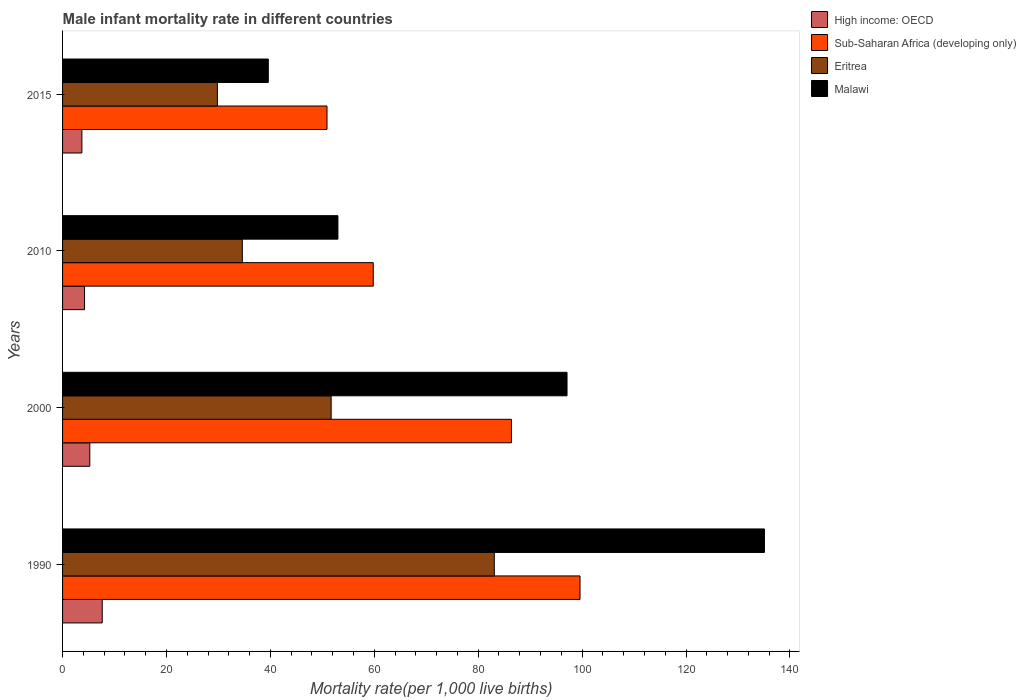How many different coloured bars are there?
Make the answer very short. 4. Are the number of bars on each tick of the Y-axis equal?
Your response must be concise. Yes. How many bars are there on the 3rd tick from the top?
Provide a short and direct response. 4. What is the label of the 1st group of bars from the top?
Offer a very short reply. 2015. What is the male infant mortality rate in Malawi in 2000?
Provide a short and direct response. 97.1. Across all years, what is the maximum male infant mortality rate in Sub-Saharan Africa (developing only)?
Make the answer very short. 99.6. Across all years, what is the minimum male infant mortality rate in Malawi?
Ensure brevity in your answer.  39.6. In which year was the male infant mortality rate in Malawi minimum?
Ensure brevity in your answer.  2015. What is the total male infant mortality rate in Malawi in the graph?
Provide a succinct answer. 324.8. What is the difference between the male infant mortality rate in High income: OECD in 2010 and that in 2015?
Keep it short and to the point. 0.51. What is the difference between the male infant mortality rate in Sub-Saharan Africa (developing only) in 1990 and the male infant mortality rate in Malawi in 2000?
Offer a terse response. 2.5. What is the average male infant mortality rate in Sub-Saharan Africa (developing only) per year?
Ensure brevity in your answer.  74.17. In the year 1990, what is the difference between the male infant mortality rate in Eritrea and male infant mortality rate in Sub-Saharan Africa (developing only)?
Ensure brevity in your answer.  -16.5. What is the ratio of the male infant mortality rate in Sub-Saharan Africa (developing only) in 2000 to that in 2015?
Give a very brief answer. 1.7. Is the male infant mortality rate in Malawi in 1990 less than that in 2000?
Ensure brevity in your answer.  No. Is the difference between the male infant mortality rate in Eritrea in 1990 and 2015 greater than the difference between the male infant mortality rate in Sub-Saharan Africa (developing only) in 1990 and 2015?
Provide a succinct answer. Yes. What is the difference between the highest and the second highest male infant mortality rate in Eritrea?
Your answer should be compact. 31.4. What is the difference between the highest and the lowest male infant mortality rate in Malawi?
Give a very brief answer. 95.5. In how many years, is the male infant mortality rate in Malawi greater than the average male infant mortality rate in Malawi taken over all years?
Your answer should be very brief. 2. What does the 4th bar from the top in 2000 represents?
Ensure brevity in your answer.  High income: OECD. What does the 4th bar from the bottom in 2015 represents?
Offer a very short reply. Malawi. Is it the case that in every year, the sum of the male infant mortality rate in Malawi and male infant mortality rate in Eritrea is greater than the male infant mortality rate in Sub-Saharan Africa (developing only)?
Your answer should be very brief. Yes. Are all the bars in the graph horizontal?
Offer a very short reply. Yes. How many years are there in the graph?
Your response must be concise. 4. Are the values on the major ticks of X-axis written in scientific E-notation?
Provide a succinct answer. No. Where does the legend appear in the graph?
Give a very brief answer. Top right. How many legend labels are there?
Offer a very short reply. 4. How are the legend labels stacked?
Your response must be concise. Vertical. What is the title of the graph?
Ensure brevity in your answer.  Male infant mortality rate in different countries. What is the label or title of the X-axis?
Offer a very short reply. Mortality rate(per 1,0 live births). What is the Mortality rate(per 1,000 live births) of High income: OECD in 1990?
Offer a terse response. 7.64. What is the Mortality rate(per 1,000 live births) in Sub-Saharan Africa (developing only) in 1990?
Offer a terse response. 99.6. What is the Mortality rate(per 1,000 live births) of Eritrea in 1990?
Offer a very short reply. 83.1. What is the Mortality rate(per 1,000 live births) in Malawi in 1990?
Ensure brevity in your answer.  135.1. What is the Mortality rate(per 1,000 live births) in High income: OECD in 2000?
Provide a short and direct response. 5.24. What is the Mortality rate(per 1,000 live births) of Sub-Saharan Africa (developing only) in 2000?
Ensure brevity in your answer.  86.4. What is the Mortality rate(per 1,000 live births) in Eritrea in 2000?
Offer a terse response. 51.7. What is the Mortality rate(per 1,000 live births) of Malawi in 2000?
Offer a terse response. 97.1. What is the Mortality rate(per 1,000 live births) in High income: OECD in 2010?
Provide a short and direct response. 4.23. What is the Mortality rate(per 1,000 live births) in Sub-Saharan Africa (developing only) in 2010?
Make the answer very short. 59.8. What is the Mortality rate(per 1,000 live births) of Eritrea in 2010?
Provide a short and direct response. 34.6. What is the Mortality rate(per 1,000 live births) of High income: OECD in 2015?
Ensure brevity in your answer.  3.72. What is the Mortality rate(per 1,000 live births) of Sub-Saharan Africa (developing only) in 2015?
Provide a succinct answer. 50.9. What is the Mortality rate(per 1,000 live births) of Eritrea in 2015?
Provide a succinct answer. 29.8. What is the Mortality rate(per 1,000 live births) in Malawi in 2015?
Make the answer very short. 39.6. Across all years, what is the maximum Mortality rate(per 1,000 live births) of High income: OECD?
Keep it short and to the point. 7.64. Across all years, what is the maximum Mortality rate(per 1,000 live births) of Sub-Saharan Africa (developing only)?
Provide a short and direct response. 99.6. Across all years, what is the maximum Mortality rate(per 1,000 live births) of Eritrea?
Your answer should be very brief. 83.1. Across all years, what is the maximum Mortality rate(per 1,000 live births) of Malawi?
Give a very brief answer. 135.1. Across all years, what is the minimum Mortality rate(per 1,000 live births) in High income: OECD?
Keep it short and to the point. 3.72. Across all years, what is the minimum Mortality rate(per 1,000 live births) in Sub-Saharan Africa (developing only)?
Your answer should be very brief. 50.9. Across all years, what is the minimum Mortality rate(per 1,000 live births) in Eritrea?
Ensure brevity in your answer.  29.8. Across all years, what is the minimum Mortality rate(per 1,000 live births) in Malawi?
Offer a very short reply. 39.6. What is the total Mortality rate(per 1,000 live births) of High income: OECD in the graph?
Give a very brief answer. 20.82. What is the total Mortality rate(per 1,000 live births) of Sub-Saharan Africa (developing only) in the graph?
Give a very brief answer. 296.7. What is the total Mortality rate(per 1,000 live births) in Eritrea in the graph?
Offer a terse response. 199.2. What is the total Mortality rate(per 1,000 live births) in Malawi in the graph?
Provide a short and direct response. 324.8. What is the difference between the Mortality rate(per 1,000 live births) in High income: OECD in 1990 and that in 2000?
Make the answer very short. 2.39. What is the difference between the Mortality rate(per 1,000 live births) of Sub-Saharan Africa (developing only) in 1990 and that in 2000?
Provide a succinct answer. 13.2. What is the difference between the Mortality rate(per 1,000 live births) of Eritrea in 1990 and that in 2000?
Provide a short and direct response. 31.4. What is the difference between the Mortality rate(per 1,000 live births) of High income: OECD in 1990 and that in 2010?
Provide a succinct answer. 3.41. What is the difference between the Mortality rate(per 1,000 live births) of Sub-Saharan Africa (developing only) in 1990 and that in 2010?
Your response must be concise. 39.8. What is the difference between the Mortality rate(per 1,000 live births) in Eritrea in 1990 and that in 2010?
Give a very brief answer. 48.5. What is the difference between the Mortality rate(per 1,000 live births) of Malawi in 1990 and that in 2010?
Keep it short and to the point. 82.1. What is the difference between the Mortality rate(per 1,000 live births) in High income: OECD in 1990 and that in 2015?
Offer a very short reply. 3.92. What is the difference between the Mortality rate(per 1,000 live births) in Sub-Saharan Africa (developing only) in 1990 and that in 2015?
Give a very brief answer. 48.7. What is the difference between the Mortality rate(per 1,000 live births) of Eritrea in 1990 and that in 2015?
Your answer should be very brief. 53.3. What is the difference between the Mortality rate(per 1,000 live births) in Malawi in 1990 and that in 2015?
Your answer should be compact. 95.5. What is the difference between the Mortality rate(per 1,000 live births) of High income: OECD in 2000 and that in 2010?
Offer a terse response. 1.01. What is the difference between the Mortality rate(per 1,000 live births) of Sub-Saharan Africa (developing only) in 2000 and that in 2010?
Offer a terse response. 26.6. What is the difference between the Mortality rate(per 1,000 live births) of Eritrea in 2000 and that in 2010?
Offer a terse response. 17.1. What is the difference between the Mortality rate(per 1,000 live births) in Malawi in 2000 and that in 2010?
Your answer should be very brief. 44.1. What is the difference between the Mortality rate(per 1,000 live births) in High income: OECD in 2000 and that in 2015?
Your answer should be compact. 1.52. What is the difference between the Mortality rate(per 1,000 live births) of Sub-Saharan Africa (developing only) in 2000 and that in 2015?
Provide a succinct answer. 35.5. What is the difference between the Mortality rate(per 1,000 live births) in Eritrea in 2000 and that in 2015?
Your response must be concise. 21.9. What is the difference between the Mortality rate(per 1,000 live births) in Malawi in 2000 and that in 2015?
Offer a very short reply. 57.5. What is the difference between the Mortality rate(per 1,000 live births) in High income: OECD in 2010 and that in 2015?
Offer a terse response. 0.51. What is the difference between the Mortality rate(per 1,000 live births) in High income: OECD in 1990 and the Mortality rate(per 1,000 live births) in Sub-Saharan Africa (developing only) in 2000?
Your answer should be compact. -78.76. What is the difference between the Mortality rate(per 1,000 live births) of High income: OECD in 1990 and the Mortality rate(per 1,000 live births) of Eritrea in 2000?
Your answer should be compact. -44.06. What is the difference between the Mortality rate(per 1,000 live births) of High income: OECD in 1990 and the Mortality rate(per 1,000 live births) of Malawi in 2000?
Your answer should be compact. -89.46. What is the difference between the Mortality rate(per 1,000 live births) in Sub-Saharan Africa (developing only) in 1990 and the Mortality rate(per 1,000 live births) in Eritrea in 2000?
Your response must be concise. 47.9. What is the difference between the Mortality rate(per 1,000 live births) in Sub-Saharan Africa (developing only) in 1990 and the Mortality rate(per 1,000 live births) in Malawi in 2000?
Make the answer very short. 2.5. What is the difference between the Mortality rate(per 1,000 live births) in High income: OECD in 1990 and the Mortality rate(per 1,000 live births) in Sub-Saharan Africa (developing only) in 2010?
Provide a short and direct response. -52.16. What is the difference between the Mortality rate(per 1,000 live births) of High income: OECD in 1990 and the Mortality rate(per 1,000 live births) of Eritrea in 2010?
Ensure brevity in your answer.  -26.96. What is the difference between the Mortality rate(per 1,000 live births) of High income: OECD in 1990 and the Mortality rate(per 1,000 live births) of Malawi in 2010?
Make the answer very short. -45.36. What is the difference between the Mortality rate(per 1,000 live births) of Sub-Saharan Africa (developing only) in 1990 and the Mortality rate(per 1,000 live births) of Malawi in 2010?
Provide a short and direct response. 46.6. What is the difference between the Mortality rate(per 1,000 live births) of Eritrea in 1990 and the Mortality rate(per 1,000 live births) of Malawi in 2010?
Keep it short and to the point. 30.1. What is the difference between the Mortality rate(per 1,000 live births) of High income: OECD in 1990 and the Mortality rate(per 1,000 live births) of Sub-Saharan Africa (developing only) in 2015?
Keep it short and to the point. -43.26. What is the difference between the Mortality rate(per 1,000 live births) in High income: OECD in 1990 and the Mortality rate(per 1,000 live births) in Eritrea in 2015?
Your answer should be very brief. -22.16. What is the difference between the Mortality rate(per 1,000 live births) of High income: OECD in 1990 and the Mortality rate(per 1,000 live births) of Malawi in 2015?
Offer a very short reply. -31.96. What is the difference between the Mortality rate(per 1,000 live births) of Sub-Saharan Africa (developing only) in 1990 and the Mortality rate(per 1,000 live births) of Eritrea in 2015?
Ensure brevity in your answer.  69.8. What is the difference between the Mortality rate(per 1,000 live births) of Sub-Saharan Africa (developing only) in 1990 and the Mortality rate(per 1,000 live births) of Malawi in 2015?
Offer a very short reply. 60. What is the difference between the Mortality rate(per 1,000 live births) in Eritrea in 1990 and the Mortality rate(per 1,000 live births) in Malawi in 2015?
Your answer should be compact. 43.5. What is the difference between the Mortality rate(per 1,000 live births) in High income: OECD in 2000 and the Mortality rate(per 1,000 live births) in Sub-Saharan Africa (developing only) in 2010?
Give a very brief answer. -54.56. What is the difference between the Mortality rate(per 1,000 live births) of High income: OECD in 2000 and the Mortality rate(per 1,000 live births) of Eritrea in 2010?
Provide a short and direct response. -29.36. What is the difference between the Mortality rate(per 1,000 live births) in High income: OECD in 2000 and the Mortality rate(per 1,000 live births) in Malawi in 2010?
Ensure brevity in your answer.  -47.76. What is the difference between the Mortality rate(per 1,000 live births) in Sub-Saharan Africa (developing only) in 2000 and the Mortality rate(per 1,000 live births) in Eritrea in 2010?
Your answer should be compact. 51.8. What is the difference between the Mortality rate(per 1,000 live births) in Sub-Saharan Africa (developing only) in 2000 and the Mortality rate(per 1,000 live births) in Malawi in 2010?
Keep it short and to the point. 33.4. What is the difference between the Mortality rate(per 1,000 live births) of Eritrea in 2000 and the Mortality rate(per 1,000 live births) of Malawi in 2010?
Ensure brevity in your answer.  -1.3. What is the difference between the Mortality rate(per 1,000 live births) in High income: OECD in 2000 and the Mortality rate(per 1,000 live births) in Sub-Saharan Africa (developing only) in 2015?
Make the answer very short. -45.66. What is the difference between the Mortality rate(per 1,000 live births) of High income: OECD in 2000 and the Mortality rate(per 1,000 live births) of Eritrea in 2015?
Give a very brief answer. -24.56. What is the difference between the Mortality rate(per 1,000 live births) in High income: OECD in 2000 and the Mortality rate(per 1,000 live births) in Malawi in 2015?
Ensure brevity in your answer.  -34.36. What is the difference between the Mortality rate(per 1,000 live births) in Sub-Saharan Africa (developing only) in 2000 and the Mortality rate(per 1,000 live births) in Eritrea in 2015?
Keep it short and to the point. 56.6. What is the difference between the Mortality rate(per 1,000 live births) in Sub-Saharan Africa (developing only) in 2000 and the Mortality rate(per 1,000 live births) in Malawi in 2015?
Give a very brief answer. 46.8. What is the difference between the Mortality rate(per 1,000 live births) of Eritrea in 2000 and the Mortality rate(per 1,000 live births) of Malawi in 2015?
Offer a very short reply. 12.1. What is the difference between the Mortality rate(per 1,000 live births) of High income: OECD in 2010 and the Mortality rate(per 1,000 live births) of Sub-Saharan Africa (developing only) in 2015?
Your answer should be very brief. -46.67. What is the difference between the Mortality rate(per 1,000 live births) of High income: OECD in 2010 and the Mortality rate(per 1,000 live births) of Eritrea in 2015?
Offer a very short reply. -25.57. What is the difference between the Mortality rate(per 1,000 live births) in High income: OECD in 2010 and the Mortality rate(per 1,000 live births) in Malawi in 2015?
Ensure brevity in your answer.  -35.37. What is the difference between the Mortality rate(per 1,000 live births) of Sub-Saharan Africa (developing only) in 2010 and the Mortality rate(per 1,000 live births) of Eritrea in 2015?
Your answer should be compact. 30. What is the difference between the Mortality rate(per 1,000 live births) in Sub-Saharan Africa (developing only) in 2010 and the Mortality rate(per 1,000 live births) in Malawi in 2015?
Give a very brief answer. 20.2. What is the difference between the Mortality rate(per 1,000 live births) of Eritrea in 2010 and the Mortality rate(per 1,000 live births) of Malawi in 2015?
Provide a short and direct response. -5. What is the average Mortality rate(per 1,000 live births) in High income: OECD per year?
Keep it short and to the point. 5.21. What is the average Mortality rate(per 1,000 live births) of Sub-Saharan Africa (developing only) per year?
Ensure brevity in your answer.  74.17. What is the average Mortality rate(per 1,000 live births) in Eritrea per year?
Your answer should be very brief. 49.8. What is the average Mortality rate(per 1,000 live births) of Malawi per year?
Your answer should be compact. 81.2. In the year 1990, what is the difference between the Mortality rate(per 1,000 live births) in High income: OECD and Mortality rate(per 1,000 live births) in Sub-Saharan Africa (developing only)?
Provide a succinct answer. -91.96. In the year 1990, what is the difference between the Mortality rate(per 1,000 live births) in High income: OECD and Mortality rate(per 1,000 live births) in Eritrea?
Give a very brief answer. -75.46. In the year 1990, what is the difference between the Mortality rate(per 1,000 live births) in High income: OECD and Mortality rate(per 1,000 live births) in Malawi?
Give a very brief answer. -127.46. In the year 1990, what is the difference between the Mortality rate(per 1,000 live births) in Sub-Saharan Africa (developing only) and Mortality rate(per 1,000 live births) in Malawi?
Make the answer very short. -35.5. In the year 1990, what is the difference between the Mortality rate(per 1,000 live births) in Eritrea and Mortality rate(per 1,000 live births) in Malawi?
Keep it short and to the point. -52. In the year 2000, what is the difference between the Mortality rate(per 1,000 live births) in High income: OECD and Mortality rate(per 1,000 live births) in Sub-Saharan Africa (developing only)?
Your answer should be compact. -81.16. In the year 2000, what is the difference between the Mortality rate(per 1,000 live births) in High income: OECD and Mortality rate(per 1,000 live births) in Eritrea?
Offer a terse response. -46.46. In the year 2000, what is the difference between the Mortality rate(per 1,000 live births) of High income: OECD and Mortality rate(per 1,000 live births) of Malawi?
Offer a terse response. -91.86. In the year 2000, what is the difference between the Mortality rate(per 1,000 live births) in Sub-Saharan Africa (developing only) and Mortality rate(per 1,000 live births) in Eritrea?
Your answer should be very brief. 34.7. In the year 2000, what is the difference between the Mortality rate(per 1,000 live births) in Eritrea and Mortality rate(per 1,000 live births) in Malawi?
Ensure brevity in your answer.  -45.4. In the year 2010, what is the difference between the Mortality rate(per 1,000 live births) of High income: OECD and Mortality rate(per 1,000 live births) of Sub-Saharan Africa (developing only)?
Your answer should be compact. -55.57. In the year 2010, what is the difference between the Mortality rate(per 1,000 live births) in High income: OECD and Mortality rate(per 1,000 live births) in Eritrea?
Offer a very short reply. -30.37. In the year 2010, what is the difference between the Mortality rate(per 1,000 live births) in High income: OECD and Mortality rate(per 1,000 live births) in Malawi?
Keep it short and to the point. -48.77. In the year 2010, what is the difference between the Mortality rate(per 1,000 live births) in Sub-Saharan Africa (developing only) and Mortality rate(per 1,000 live births) in Eritrea?
Make the answer very short. 25.2. In the year 2010, what is the difference between the Mortality rate(per 1,000 live births) in Sub-Saharan Africa (developing only) and Mortality rate(per 1,000 live births) in Malawi?
Offer a terse response. 6.8. In the year 2010, what is the difference between the Mortality rate(per 1,000 live births) in Eritrea and Mortality rate(per 1,000 live births) in Malawi?
Provide a short and direct response. -18.4. In the year 2015, what is the difference between the Mortality rate(per 1,000 live births) in High income: OECD and Mortality rate(per 1,000 live births) in Sub-Saharan Africa (developing only)?
Offer a terse response. -47.18. In the year 2015, what is the difference between the Mortality rate(per 1,000 live births) in High income: OECD and Mortality rate(per 1,000 live births) in Eritrea?
Your response must be concise. -26.08. In the year 2015, what is the difference between the Mortality rate(per 1,000 live births) in High income: OECD and Mortality rate(per 1,000 live births) in Malawi?
Give a very brief answer. -35.88. In the year 2015, what is the difference between the Mortality rate(per 1,000 live births) in Sub-Saharan Africa (developing only) and Mortality rate(per 1,000 live births) in Eritrea?
Offer a terse response. 21.1. In the year 2015, what is the difference between the Mortality rate(per 1,000 live births) of Sub-Saharan Africa (developing only) and Mortality rate(per 1,000 live births) of Malawi?
Ensure brevity in your answer.  11.3. In the year 2015, what is the difference between the Mortality rate(per 1,000 live births) in Eritrea and Mortality rate(per 1,000 live births) in Malawi?
Offer a terse response. -9.8. What is the ratio of the Mortality rate(per 1,000 live births) in High income: OECD in 1990 to that in 2000?
Keep it short and to the point. 1.46. What is the ratio of the Mortality rate(per 1,000 live births) of Sub-Saharan Africa (developing only) in 1990 to that in 2000?
Keep it short and to the point. 1.15. What is the ratio of the Mortality rate(per 1,000 live births) of Eritrea in 1990 to that in 2000?
Give a very brief answer. 1.61. What is the ratio of the Mortality rate(per 1,000 live births) of Malawi in 1990 to that in 2000?
Make the answer very short. 1.39. What is the ratio of the Mortality rate(per 1,000 live births) of High income: OECD in 1990 to that in 2010?
Offer a terse response. 1.81. What is the ratio of the Mortality rate(per 1,000 live births) of Sub-Saharan Africa (developing only) in 1990 to that in 2010?
Your answer should be very brief. 1.67. What is the ratio of the Mortality rate(per 1,000 live births) of Eritrea in 1990 to that in 2010?
Offer a very short reply. 2.4. What is the ratio of the Mortality rate(per 1,000 live births) of Malawi in 1990 to that in 2010?
Your answer should be compact. 2.55. What is the ratio of the Mortality rate(per 1,000 live births) in High income: OECD in 1990 to that in 2015?
Provide a succinct answer. 2.05. What is the ratio of the Mortality rate(per 1,000 live births) of Sub-Saharan Africa (developing only) in 1990 to that in 2015?
Provide a short and direct response. 1.96. What is the ratio of the Mortality rate(per 1,000 live births) in Eritrea in 1990 to that in 2015?
Give a very brief answer. 2.79. What is the ratio of the Mortality rate(per 1,000 live births) in Malawi in 1990 to that in 2015?
Give a very brief answer. 3.41. What is the ratio of the Mortality rate(per 1,000 live births) in High income: OECD in 2000 to that in 2010?
Your response must be concise. 1.24. What is the ratio of the Mortality rate(per 1,000 live births) in Sub-Saharan Africa (developing only) in 2000 to that in 2010?
Ensure brevity in your answer.  1.44. What is the ratio of the Mortality rate(per 1,000 live births) in Eritrea in 2000 to that in 2010?
Your answer should be very brief. 1.49. What is the ratio of the Mortality rate(per 1,000 live births) in Malawi in 2000 to that in 2010?
Offer a very short reply. 1.83. What is the ratio of the Mortality rate(per 1,000 live births) of High income: OECD in 2000 to that in 2015?
Ensure brevity in your answer.  1.41. What is the ratio of the Mortality rate(per 1,000 live births) of Sub-Saharan Africa (developing only) in 2000 to that in 2015?
Provide a short and direct response. 1.7. What is the ratio of the Mortality rate(per 1,000 live births) of Eritrea in 2000 to that in 2015?
Offer a terse response. 1.73. What is the ratio of the Mortality rate(per 1,000 live births) in Malawi in 2000 to that in 2015?
Provide a succinct answer. 2.45. What is the ratio of the Mortality rate(per 1,000 live births) of High income: OECD in 2010 to that in 2015?
Provide a succinct answer. 1.14. What is the ratio of the Mortality rate(per 1,000 live births) of Sub-Saharan Africa (developing only) in 2010 to that in 2015?
Provide a short and direct response. 1.17. What is the ratio of the Mortality rate(per 1,000 live births) in Eritrea in 2010 to that in 2015?
Provide a succinct answer. 1.16. What is the ratio of the Mortality rate(per 1,000 live births) of Malawi in 2010 to that in 2015?
Your answer should be very brief. 1.34. What is the difference between the highest and the second highest Mortality rate(per 1,000 live births) of High income: OECD?
Offer a terse response. 2.39. What is the difference between the highest and the second highest Mortality rate(per 1,000 live births) in Eritrea?
Keep it short and to the point. 31.4. What is the difference between the highest and the second highest Mortality rate(per 1,000 live births) in Malawi?
Ensure brevity in your answer.  38. What is the difference between the highest and the lowest Mortality rate(per 1,000 live births) of High income: OECD?
Provide a succinct answer. 3.92. What is the difference between the highest and the lowest Mortality rate(per 1,000 live births) of Sub-Saharan Africa (developing only)?
Provide a short and direct response. 48.7. What is the difference between the highest and the lowest Mortality rate(per 1,000 live births) of Eritrea?
Your response must be concise. 53.3. What is the difference between the highest and the lowest Mortality rate(per 1,000 live births) of Malawi?
Make the answer very short. 95.5. 